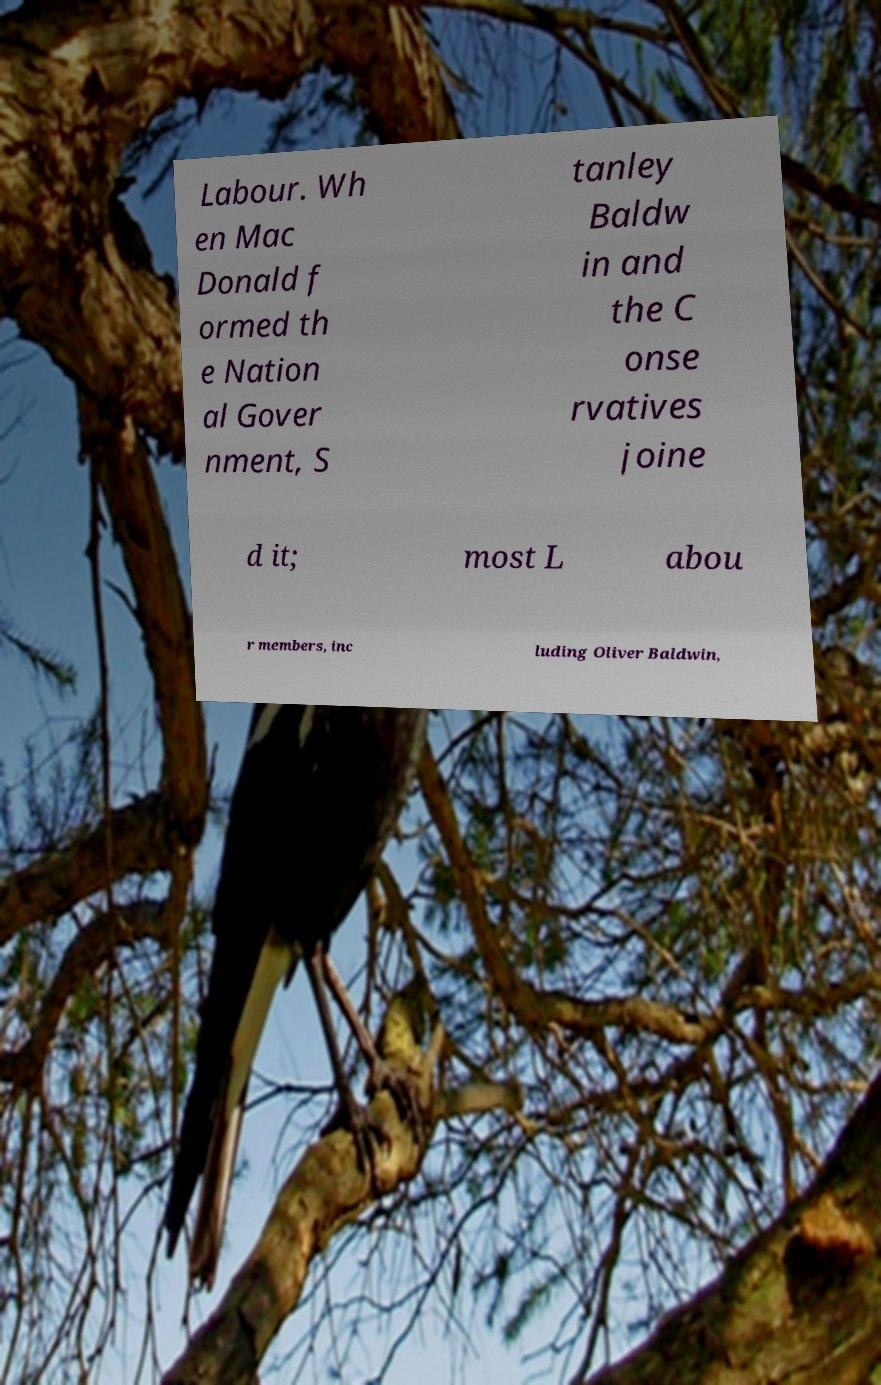Can you read and provide the text displayed in the image?This photo seems to have some interesting text. Can you extract and type it out for me? Labour. Wh en Mac Donald f ormed th e Nation al Gover nment, S tanley Baldw in and the C onse rvatives joine d it; most L abou r members, inc luding Oliver Baldwin, 